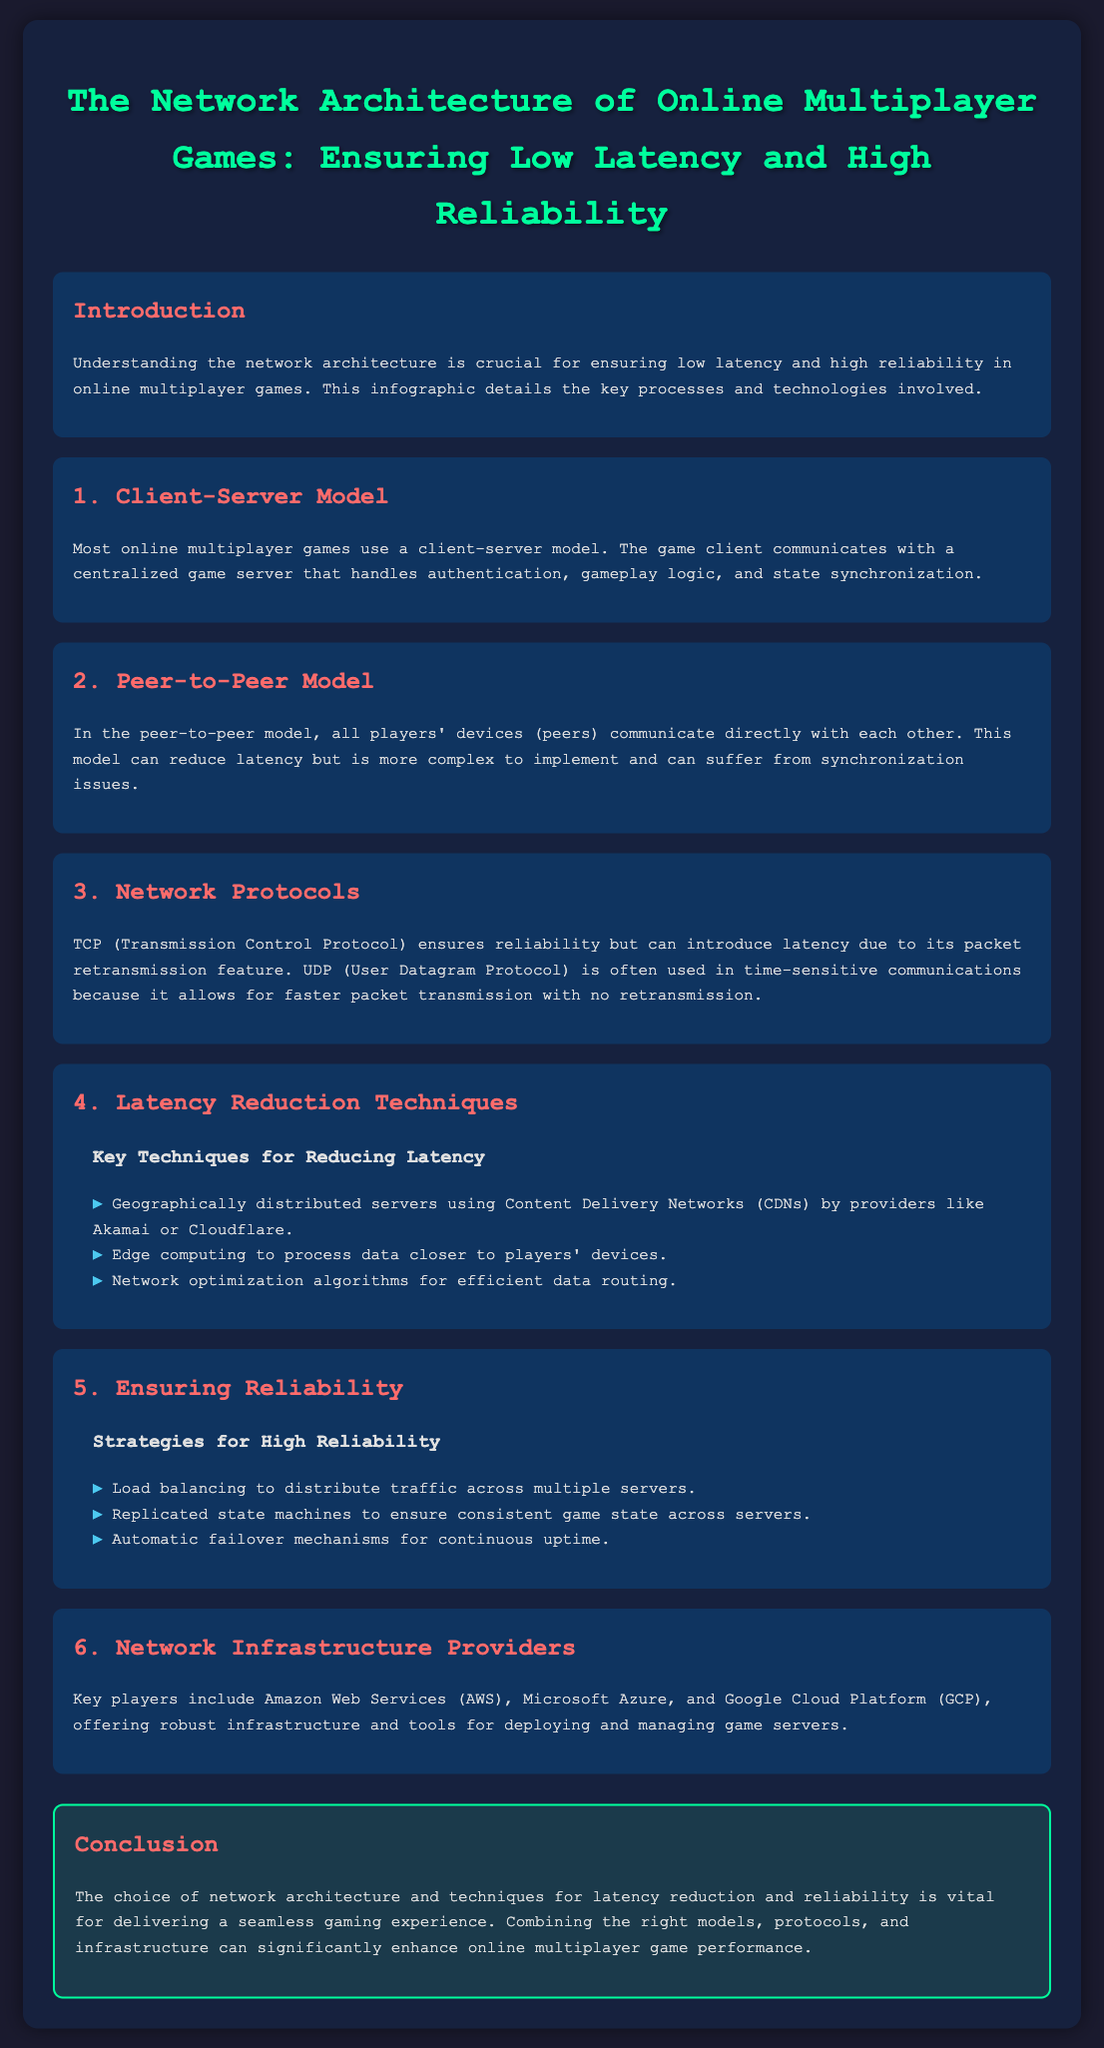What is the title of the infographic? The title provides the main topic of the document, which is stated at the top.
Answer: The Network Architecture of Online Multiplayer Games: Ensuring Low Latency and High Reliability What is the first network model mentioned? The first model discussed is a standard in online multiplayer games and is detailed in the second part of the infographic.
Answer: Client-Server Model Which protocol ensures reliability? The document specifies different network protocols, and one is highlighted for its reliability feature.
Answer: TCP What technique is used for loading balancing? The infographic mentions specific strategies in the reliability section, including one that relates to traffic distribution.
Answer: Load balancing Which providers are key players in network infrastructure? The document lists major companies that provide network infrastructure services, which is relevant to the last process step.
Answer: Amazon Web Services, Microsoft Azure, Google Cloud Platform How many steps are detailed in the infographic? The main sections of the infographic number the steps involved in the architecture process.
Answer: Six What is the goal of the network architecture discussed? The conclusion summarizes the main aim addressed throughout the infographic.
Answer: Delivering a seamless gaming experience What is one latency reduction technique mentioned? The document details specific methods for reducing latency and lists one technique under that section.
Answer: Geographically distributed servers What color is used for the headings in the process steps? The document uses specific colors to enhance readability and differentiate sections, particularly for headings.
Answer: Red 